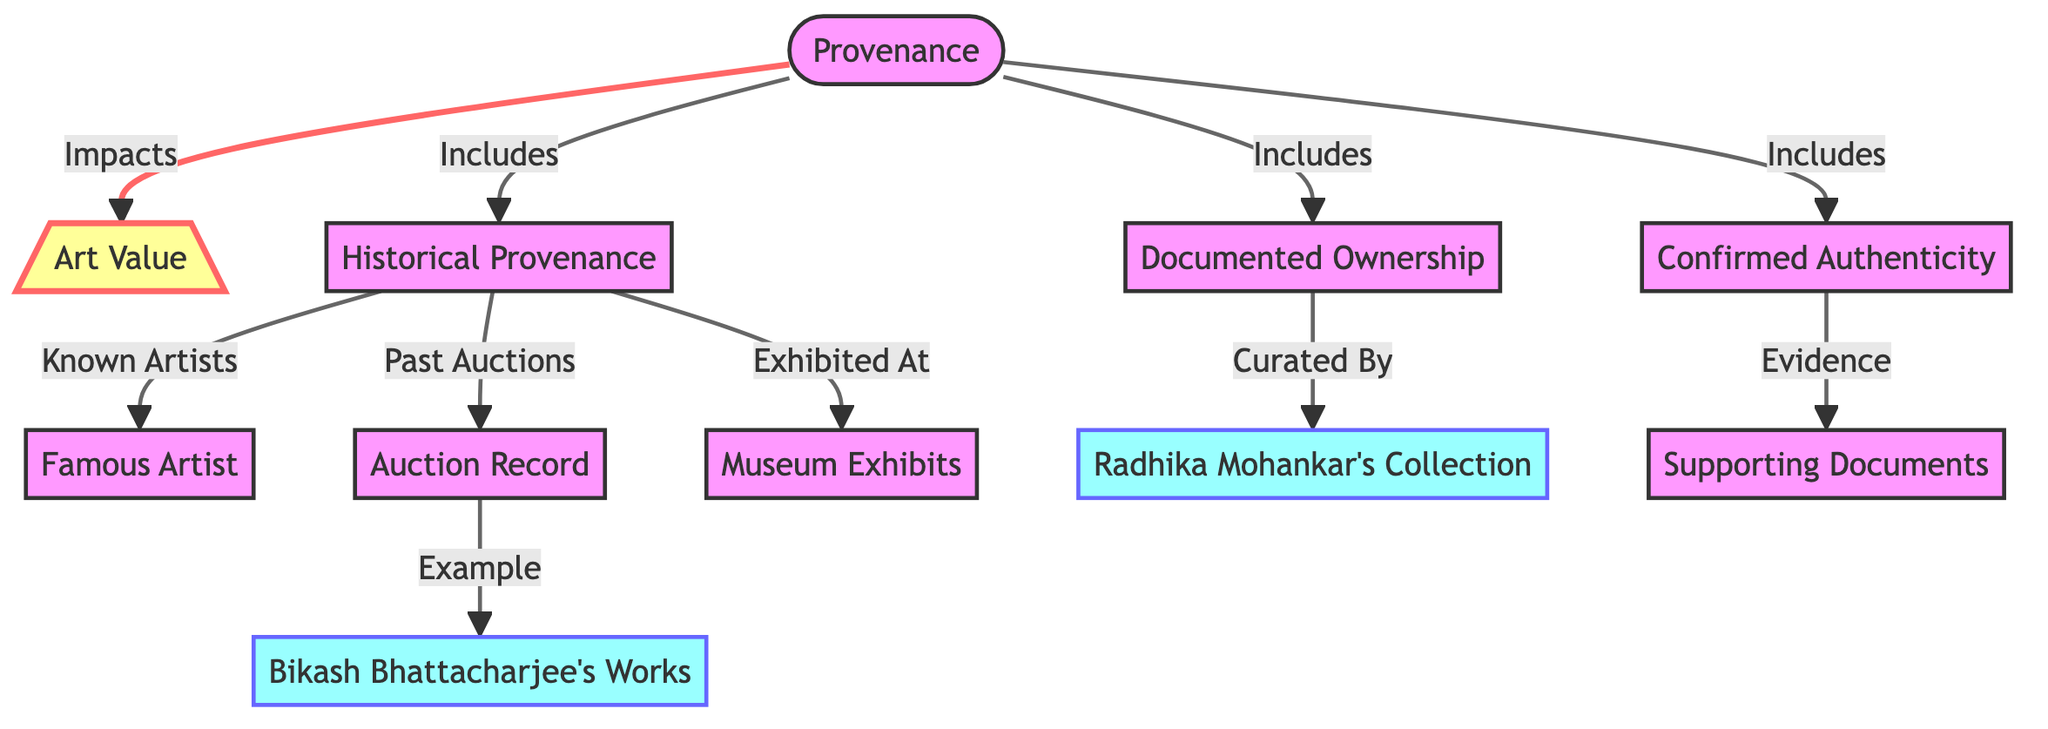What is the main node that impacts art value? The main node that impacts art value is "Provenance." It is connected with an edge to the "Art Value" node, indicating it has a direct influence on the value of the artwork.
Answer: Provenance How many types of provenance are included in the diagram? The diagram indicates three types of provenance: "Historical Provenance," "Documented Ownership," and "Confirmed Authenticity." This can be determined by counting the nodes that connect directly to the "Provenance" node.
Answer: Three Who curated documented ownership? "Documented Ownership" is curated by "Radhika Mohankar," as indicated by the directed edge leading from documented ownership to that node in the diagram.
Answer: Radhika Mohankar What is an example of historical provenance? An example of historical provenance is given in the node "Auction Record," which is connected to "Historical Provenance." This shows that auction records are a specific form of historical provenance.
Answer: Auction Record Which famous artist's works are noted as an example in the diagram? The diagram includes "Bikash Bhattacharjee's Works" as an example of historical provenance, specifically listed under the "Auction Record" node.
Answer: Bikash Bhattacharjee What type of evidence supports confirmed authenticity? Confirmed authenticity is supported by "Supporting Documents," as stated in the relationship shown in the diagram. This indicates that supporting documents provide the necessary evidence for establishing authenticity.
Answer: Supporting Documents What relationship exists between historical provenance and museum exhibits? The relationship is that historical provenance includes "Museum Exhibits." This indicates that the history of an artwork's provenance is linked to whether it has been exhibited in museums.
Answer: Exhibited At How many nodes related to provenance are categorized as examples? There are two nodes categorized as examples in the diagram: "Bikash Bhattacharjee's Works" and "Radhika Mohankar's Collection." This is determined by identifying the nodes that are specifically styled as examples in the diagram.
Answer: Two What does historical provenance include concerning artists? Historical provenance includes "Known Artists," as shown in the edge from "Historical Provenance" to the "Famous Artist" node in the diagram. This implies that knowledge of artists is integral to understanding provenance.
Answer: Known Artists 